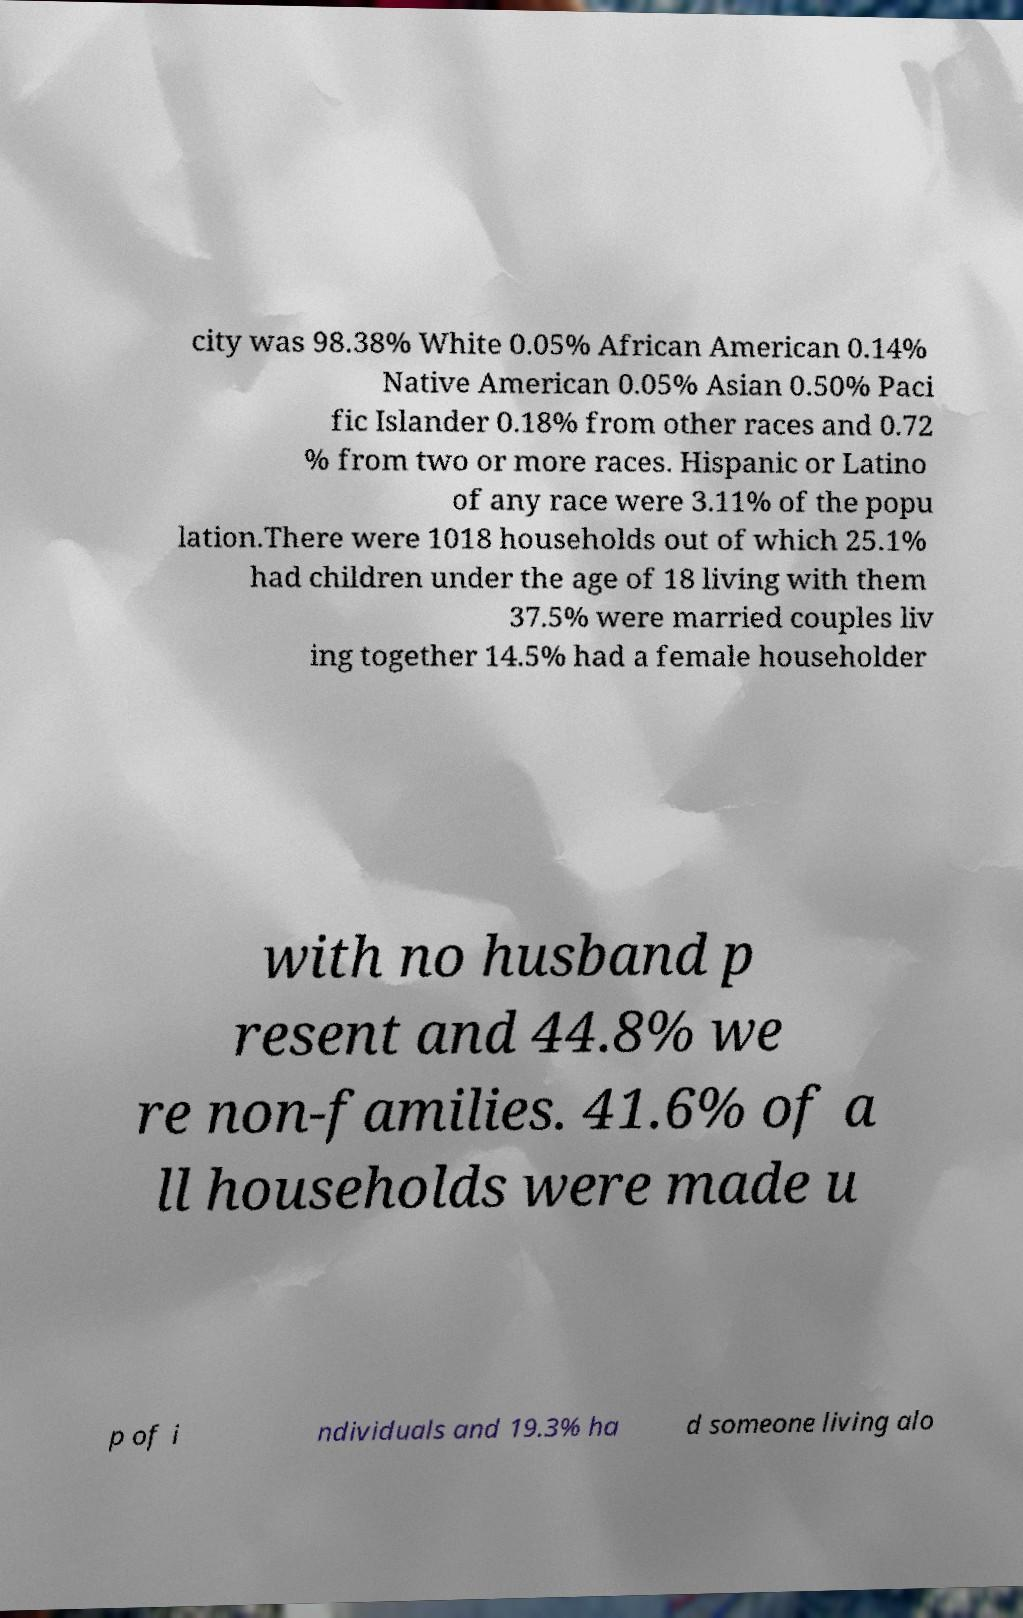For documentation purposes, I need the text within this image transcribed. Could you provide that? city was 98.38% White 0.05% African American 0.14% Native American 0.05% Asian 0.50% Paci fic Islander 0.18% from other races and 0.72 % from two or more races. Hispanic or Latino of any race were 3.11% of the popu lation.There were 1018 households out of which 25.1% had children under the age of 18 living with them 37.5% were married couples liv ing together 14.5% had a female householder with no husband p resent and 44.8% we re non-families. 41.6% of a ll households were made u p of i ndividuals and 19.3% ha d someone living alo 